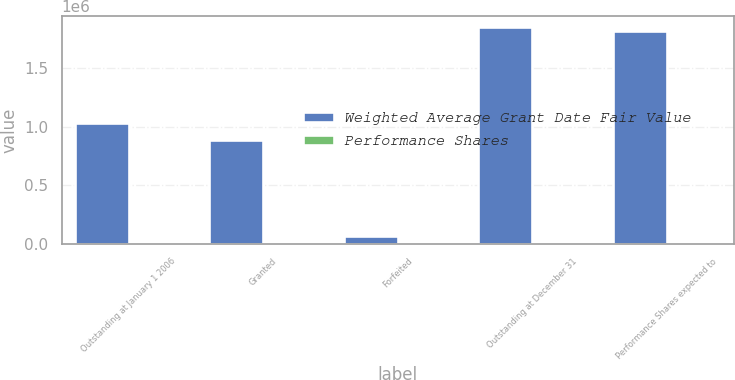Convert chart. <chart><loc_0><loc_0><loc_500><loc_500><stacked_bar_chart><ecel><fcel>Outstanding at January 1 2006<fcel>Granted<fcel>Forfeited<fcel>Outstanding at December 31<fcel>Performance Shares expected to<nl><fcel>Weighted Average Grant Date Fair Value<fcel>1.0297e+06<fcel>884875<fcel>65000<fcel>1.84958e+06<fcel>1.82074e+06<nl><fcel>Performance Shares<fcel>36.87<fcel>48.43<fcel>41.37<fcel>42.24<fcel>42.16<nl></chart> 